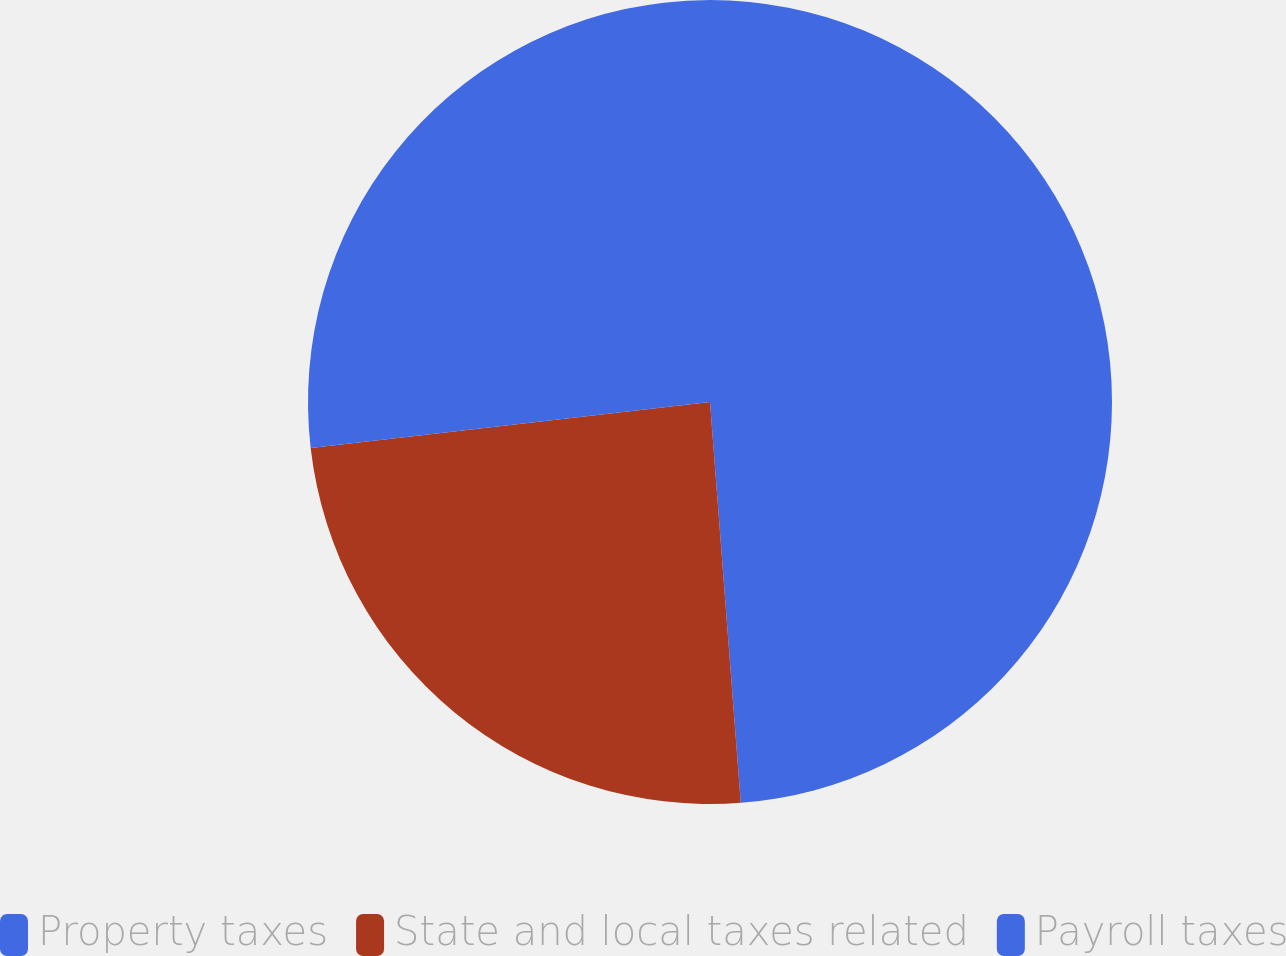Convert chart. <chart><loc_0><loc_0><loc_500><loc_500><pie_chart><fcel>Property taxes<fcel>State and local taxes related<fcel>Payroll taxes<nl><fcel>48.78%<fcel>24.39%<fcel>26.83%<nl></chart> 